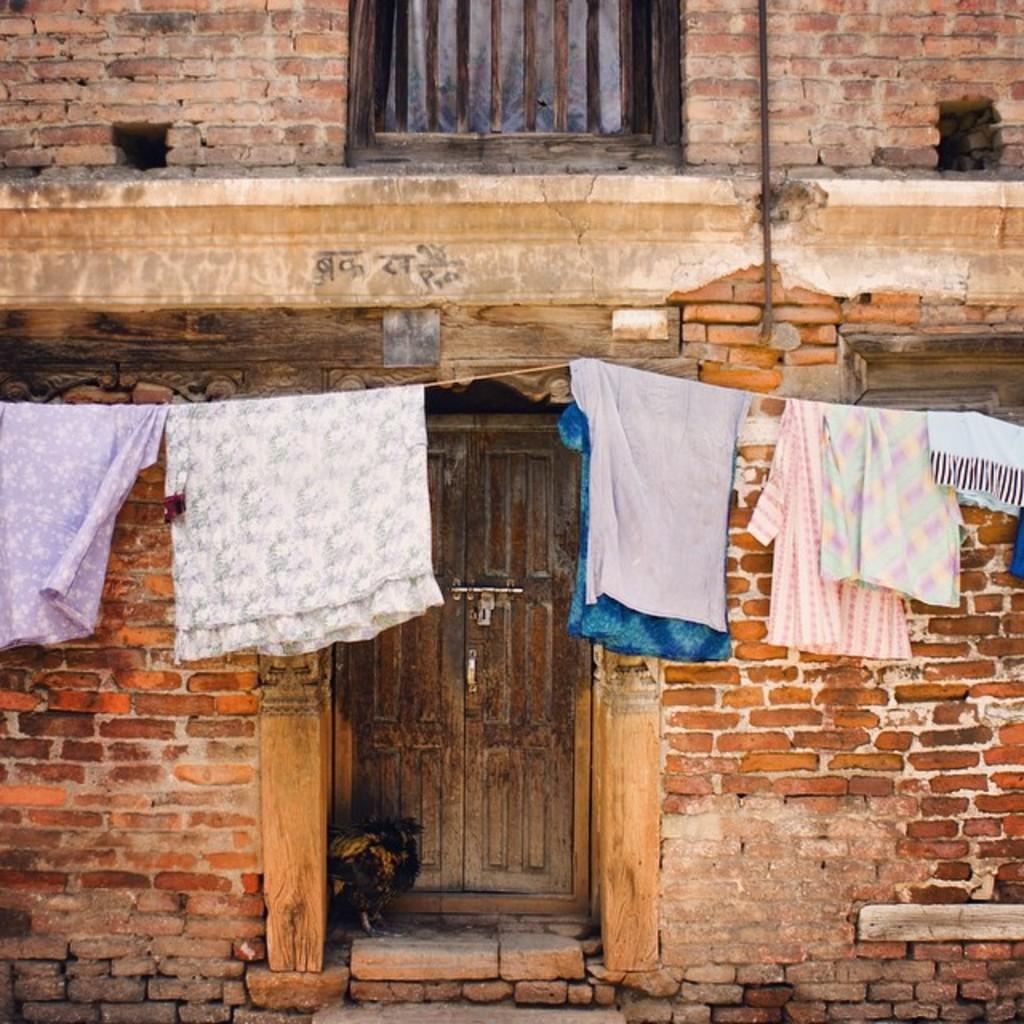What type of wall is in the image? There is a brick wall in the image. What is the door made of in the image? The door is made of wood. Where is the window located in the image? The window is visible at the top of the image. What is hanging in front of the wall in the image? Clothes are hanging on a rope in front of the wall. Can you see a rose growing near the wooden door in the image? There is no rose visible in the image. Is there a porter carrying luggage near the brick wall in the image? There is no porter or luggage present in the image. 